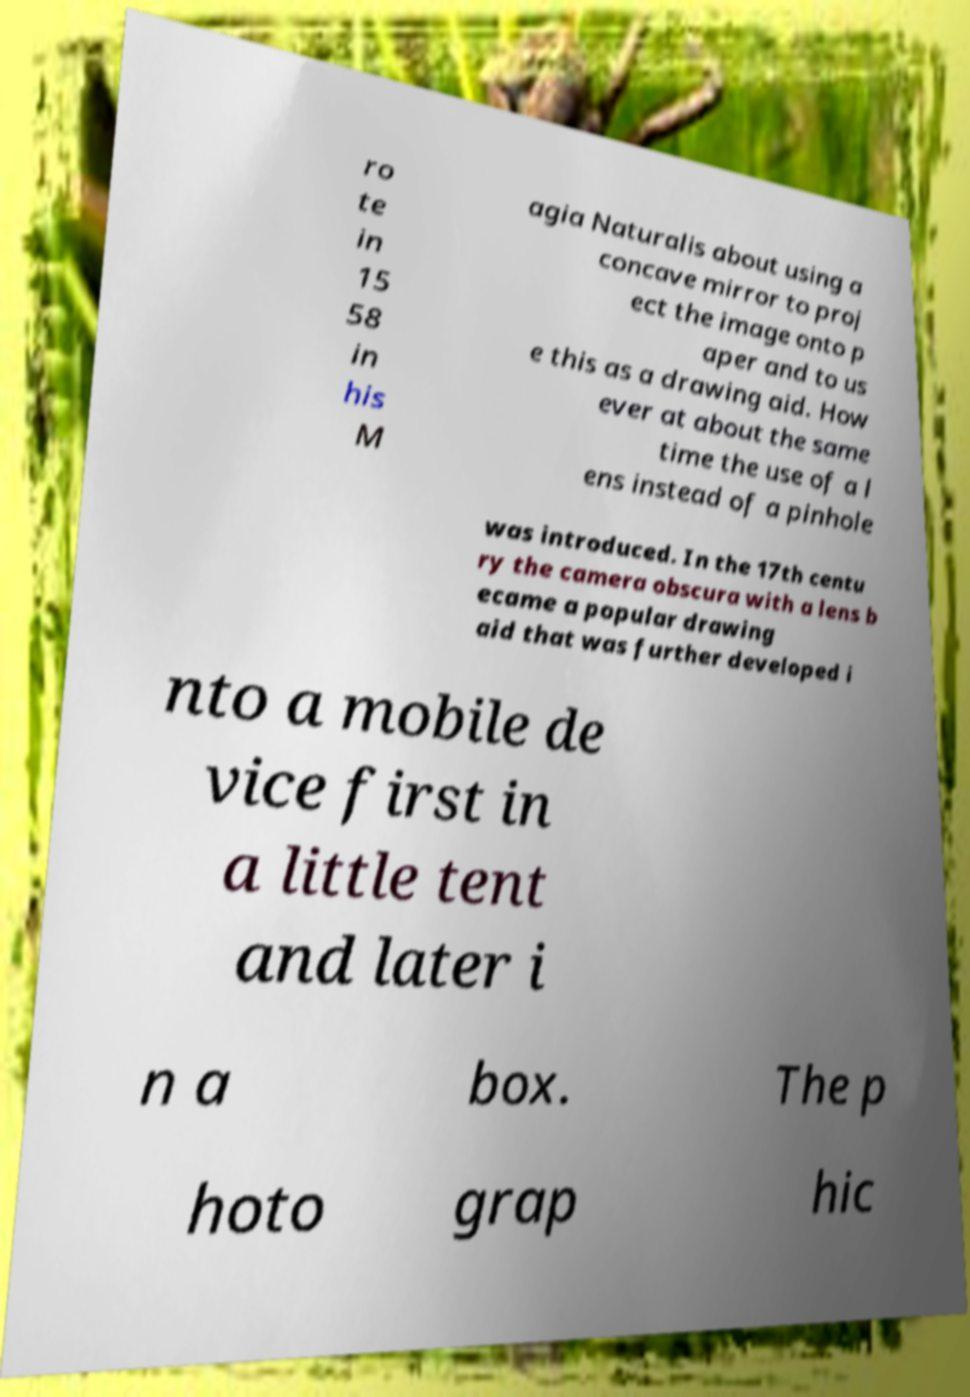Could you extract and type out the text from this image? ro te in 15 58 in his M agia Naturalis about using a concave mirror to proj ect the image onto p aper and to us e this as a drawing aid. How ever at about the same time the use of a l ens instead of a pinhole was introduced. In the 17th centu ry the camera obscura with a lens b ecame a popular drawing aid that was further developed i nto a mobile de vice first in a little tent and later i n a box. The p hoto grap hic 